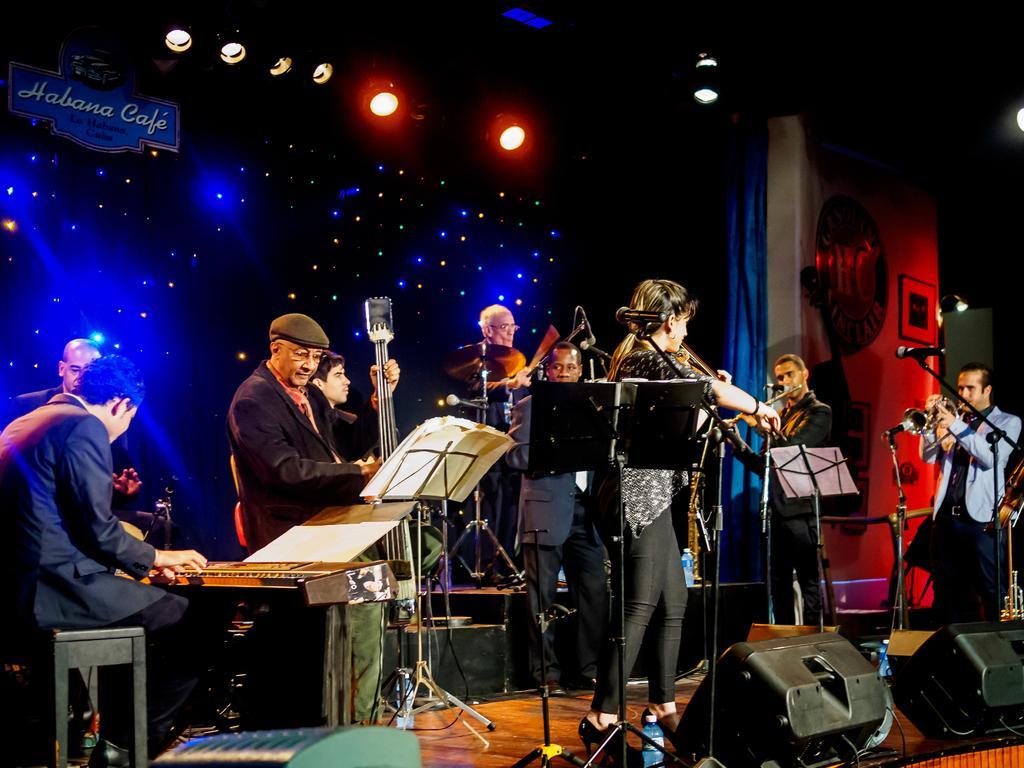How would you summarize this image in a sentence or two? Here people are standing, these are musical instruments, these are lights, these are speakers. 